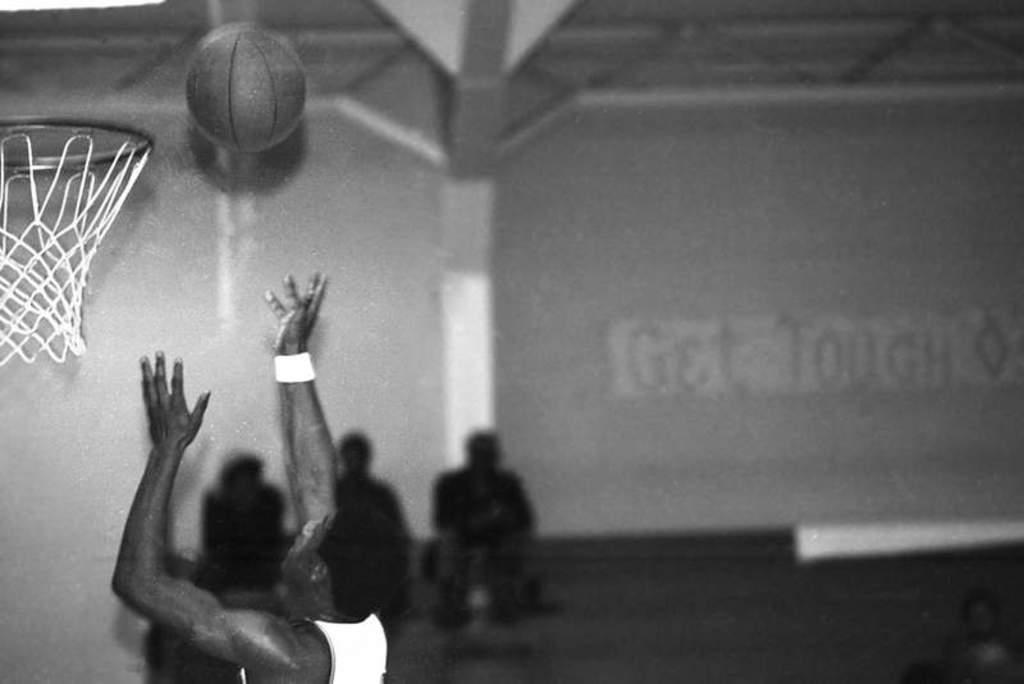What is the color scheme of the image? The image is black and white. What is the man in the image doing? The man is throwing a basketball. What is the intended target of the basketball? The basketball is being thrown into a basket. How would you describe the background of the image? The background of the image is blurry. Can you identify any other people in the image? Yes, there are three men sitting on a bench in the background. What type of scarf is the fairy wearing in the image? There are no fairies or scarves present in the image. What is the servant doing in the image? There are no servants present in the image. 